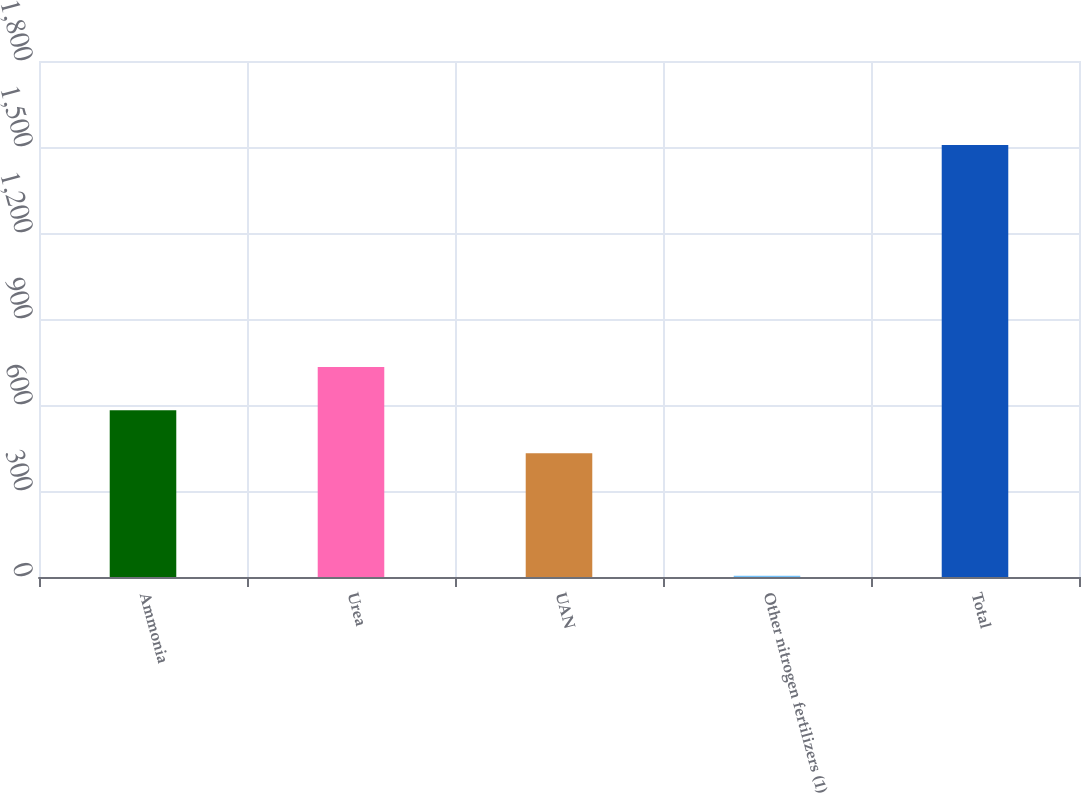<chart> <loc_0><loc_0><loc_500><loc_500><bar_chart><fcel>Ammonia<fcel>Urea<fcel>UAN<fcel>Other nitrogen fertilizers (1)<fcel>Total<nl><fcel>581.97<fcel>732.24<fcel>431.7<fcel>4.1<fcel>1506.8<nl></chart> 